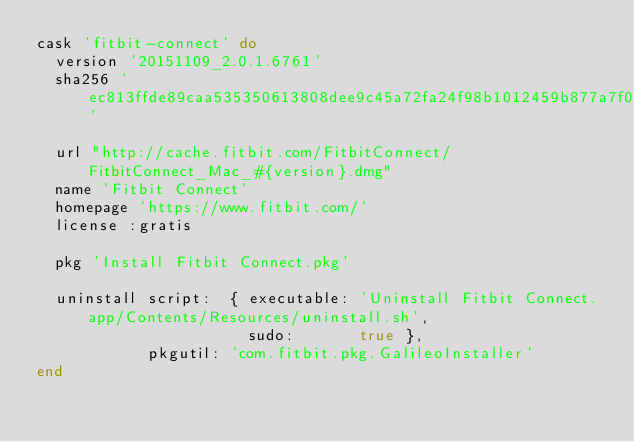Convert code to text. <code><loc_0><loc_0><loc_500><loc_500><_Ruby_>cask 'fitbit-connect' do
  version '20151109_2.0.1.6761'
  sha256 'ec813ffde89caa535350613808dee9c45a72fa24f98b1012459b877a7f0f9e2c'

  url "http://cache.fitbit.com/FitbitConnect/FitbitConnect_Mac_#{version}.dmg"
  name 'Fitbit Connect'
  homepage 'https://www.fitbit.com/'
  license :gratis

  pkg 'Install Fitbit Connect.pkg'

  uninstall script:  { executable: 'Uninstall Fitbit Connect.app/Contents/Resources/uninstall.sh',
                       sudo:       true },
            pkgutil: 'com.fitbit.pkg.GalileoInstaller'
end
</code> 